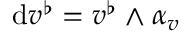Convert formula to latex. <formula><loc_0><loc_0><loc_500><loc_500>d v ^ { \flat } = v ^ { \flat } \wedge \alpha _ { v }</formula> 